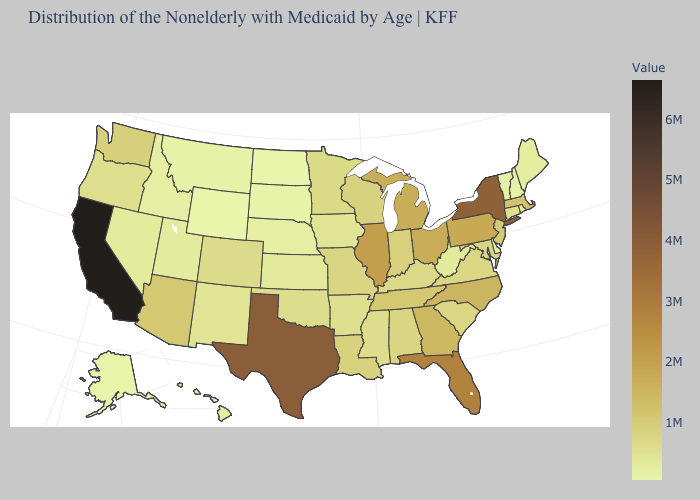Does Wyoming have the lowest value in the USA?
Write a very short answer. Yes. Is the legend a continuous bar?
Write a very short answer. Yes. Is the legend a continuous bar?
Keep it brief. Yes. Which states have the lowest value in the South?
Short answer required. Delaware. Among the states that border Arizona , which have the lowest value?
Short answer required. Utah. Does Texas have a lower value than California?
Write a very short answer. Yes. Which states hav the highest value in the Northeast?
Quick response, please. New York. 